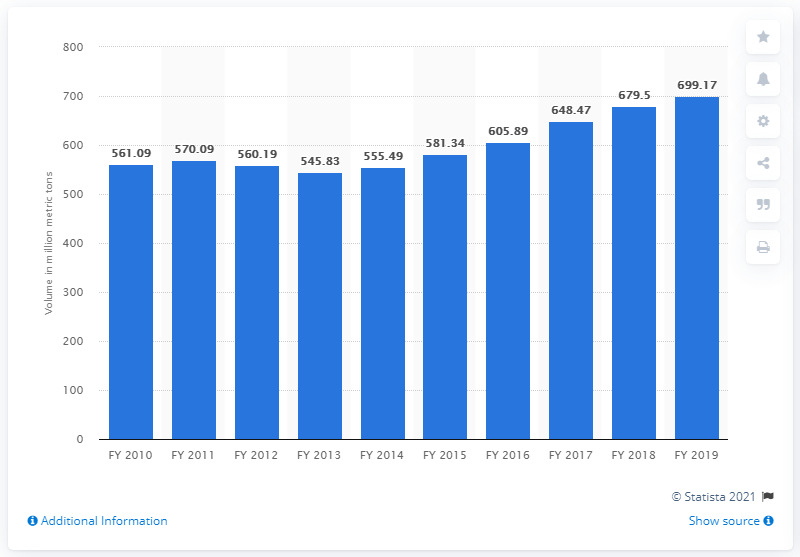Specify some key components in this picture. India's cargo volume in 2019 was 699.17 million metric tons. 